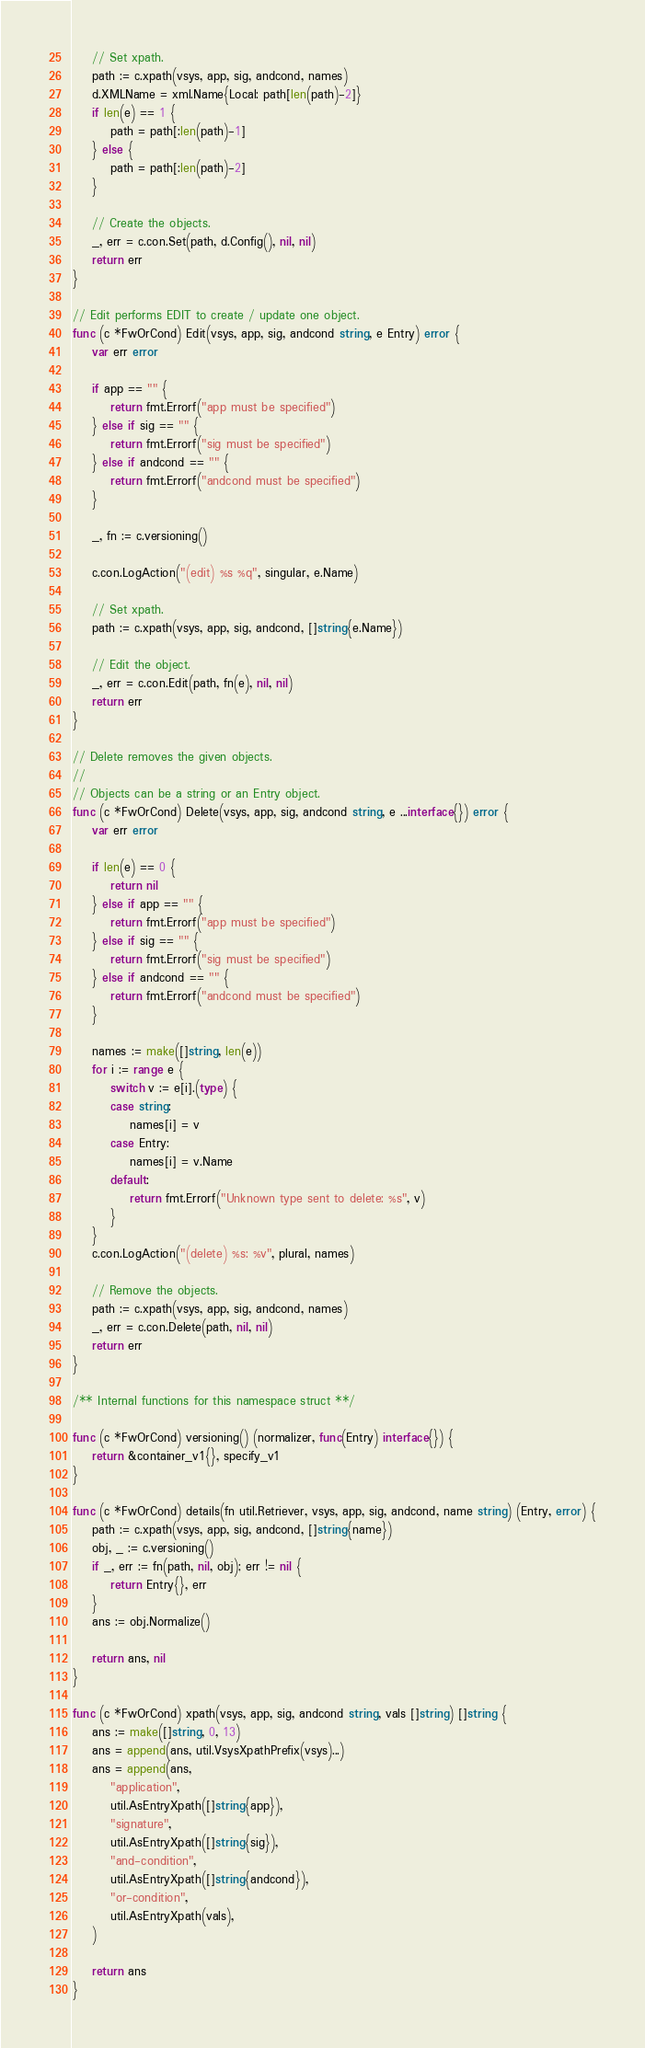<code> <loc_0><loc_0><loc_500><loc_500><_Go_>
	// Set xpath.
	path := c.xpath(vsys, app, sig, andcond, names)
	d.XMLName = xml.Name{Local: path[len(path)-2]}
	if len(e) == 1 {
		path = path[:len(path)-1]
	} else {
		path = path[:len(path)-2]
	}

	// Create the objects.
	_, err = c.con.Set(path, d.Config(), nil, nil)
	return err
}

// Edit performs EDIT to create / update one object.
func (c *FwOrCond) Edit(vsys, app, sig, andcond string, e Entry) error {
	var err error

	if app == "" {
		return fmt.Errorf("app must be specified")
	} else if sig == "" {
		return fmt.Errorf("sig must be specified")
	} else if andcond == "" {
		return fmt.Errorf("andcond must be specified")
	}

	_, fn := c.versioning()

	c.con.LogAction("(edit) %s %q", singular, e.Name)

	// Set xpath.
	path := c.xpath(vsys, app, sig, andcond, []string{e.Name})

	// Edit the object.
	_, err = c.con.Edit(path, fn(e), nil, nil)
	return err
}

// Delete removes the given objects.
//
// Objects can be a string or an Entry object.
func (c *FwOrCond) Delete(vsys, app, sig, andcond string, e ...interface{}) error {
	var err error

	if len(e) == 0 {
		return nil
	} else if app == "" {
		return fmt.Errorf("app must be specified")
	} else if sig == "" {
		return fmt.Errorf("sig must be specified")
	} else if andcond == "" {
		return fmt.Errorf("andcond must be specified")
	}

	names := make([]string, len(e))
	for i := range e {
		switch v := e[i].(type) {
		case string:
			names[i] = v
		case Entry:
			names[i] = v.Name
		default:
			return fmt.Errorf("Unknown type sent to delete: %s", v)
		}
	}
	c.con.LogAction("(delete) %s: %v", plural, names)

	// Remove the objects.
	path := c.xpath(vsys, app, sig, andcond, names)
	_, err = c.con.Delete(path, nil, nil)
	return err
}

/** Internal functions for this namespace struct **/

func (c *FwOrCond) versioning() (normalizer, func(Entry) interface{}) {
	return &container_v1{}, specify_v1
}

func (c *FwOrCond) details(fn util.Retriever, vsys, app, sig, andcond, name string) (Entry, error) {
	path := c.xpath(vsys, app, sig, andcond, []string{name})
	obj, _ := c.versioning()
	if _, err := fn(path, nil, obj); err != nil {
		return Entry{}, err
	}
	ans := obj.Normalize()

	return ans, nil
}

func (c *FwOrCond) xpath(vsys, app, sig, andcond string, vals []string) []string {
	ans := make([]string, 0, 13)
	ans = append(ans, util.VsysXpathPrefix(vsys)...)
	ans = append(ans,
		"application",
		util.AsEntryXpath([]string{app}),
		"signature",
		util.AsEntryXpath([]string{sig}),
		"and-condition",
		util.AsEntryXpath([]string{andcond}),
		"or-condition",
		util.AsEntryXpath(vals),
	)

	return ans
}
</code> 